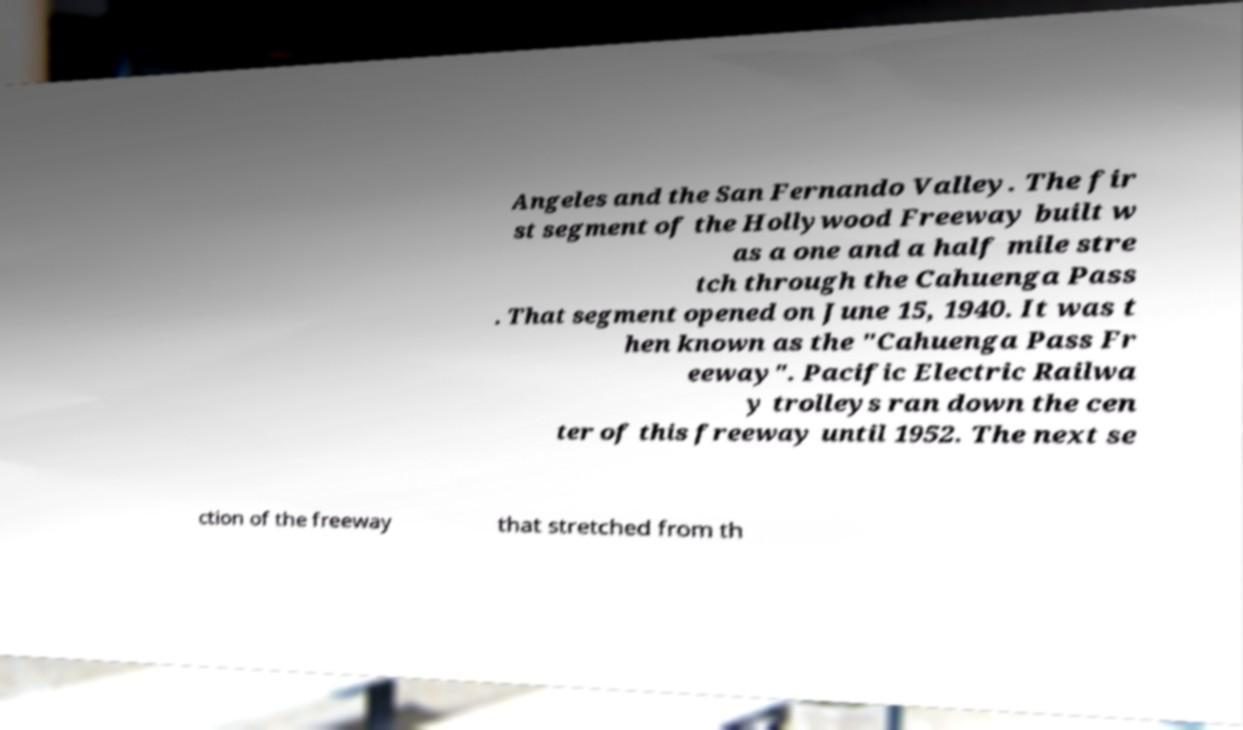Could you assist in decoding the text presented in this image and type it out clearly? Angeles and the San Fernando Valley. The fir st segment of the Hollywood Freeway built w as a one and a half mile stre tch through the Cahuenga Pass . That segment opened on June 15, 1940. It was t hen known as the "Cahuenga Pass Fr eeway". Pacific Electric Railwa y trolleys ran down the cen ter of this freeway until 1952. The next se ction of the freeway that stretched from th 